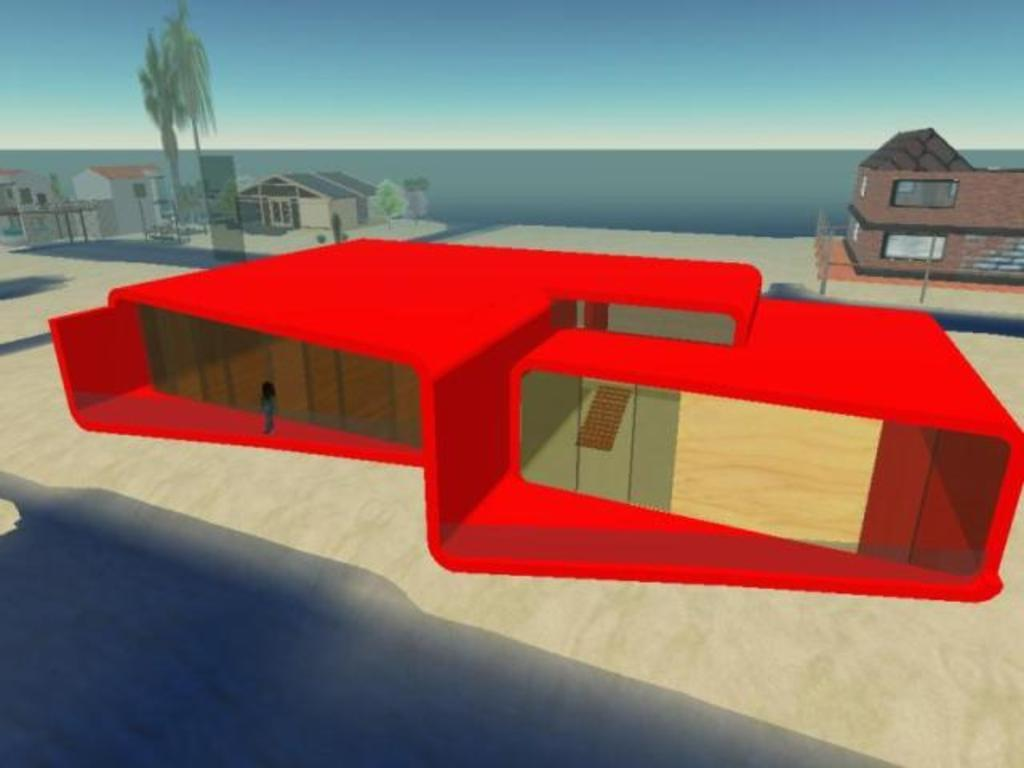What type of image is this? The image is animated. What is the main subject in the center of the image? There is a house in the center of the image. Can you describe the person in the image? There is a person in the image. What can be seen in the background of the image? There are buildings, trees, water, and the sky visible in the background of the image. What type of knowledge is being taught at the zoo in the image? There is no zoo present in the image, so it is not possible to determine what type of knowledge might be taught there. 